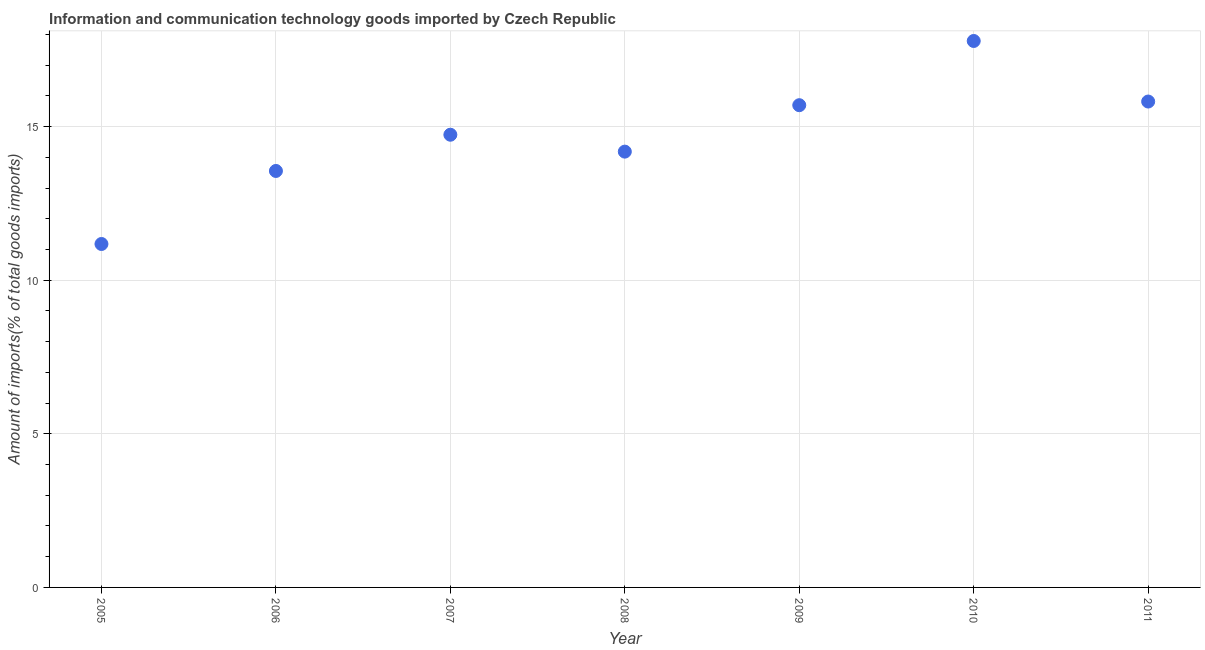What is the amount of ict goods imports in 2006?
Provide a succinct answer. 13.56. Across all years, what is the maximum amount of ict goods imports?
Your response must be concise. 17.79. Across all years, what is the minimum amount of ict goods imports?
Give a very brief answer. 11.18. In which year was the amount of ict goods imports minimum?
Your answer should be compact. 2005. What is the sum of the amount of ict goods imports?
Your answer should be compact. 102.95. What is the difference between the amount of ict goods imports in 2006 and 2008?
Offer a terse response. -0.63. What is the average amount of ict goods imports per year?
Provide a short and direct response. 14.71. What is the median amount of ict goods imports?
Offer a very short reply. 14.74. In how many years, is the amount of ict goods imports greater than 16 %?
Provide a short and direct response. 1. Do a majority of the years between 2009 and 2006 (inclusive) have amount of ict goods imports greater than 17 %?
Your answer should be very brief. Yes. What is the ratio of the amount of ict goods imports in 2007 to that in 2008?
Keep it short and to the point. 1.04. Is the amount of ict goods imports in 2006 less than that in 2009?
Provide a succinct answer. Yes. What is the difference between the highest and the second highest amount of ict goods imports?
Your answer should be very brief. 1.97. Is the sum of the amount of ict goods imports in 2008 and 2011 greater than the maximum amount of ict goods imports across all years?
Give a very brief answer. Yes. What is the difference between the highest and the lowest amount of ict goods imports?
Keep it short and to the point. 6.61. In how many years, is the amount of ict goods imports greater than the average amount of ict goods imports taken over all years?
Your answer should be compact. 4. How many dotlines are there?
Keep it short and to the point. 1. How many years are there in the graph?
Your answer should be very brief. 7. What is the difference between two consecutive major ticks on the Y-axis?
Provide a short and direct response. 5. Does the graph contain any zero values?
Ensure brevity in your answer.  No. What is the title of the graph?
Your answer should be compact. Information and communication technology goods imported by Czech Republic. What is the label or title of the Y-axis?
Ensure brevity in your answer.  Amount of imports(% of total goods imports). What is the Amount of imports(% of total goods imports) in 2005?
Your answer should be compact. 11.18. What is the Amount of imports(% of total goods imports) in 2006?
Provide a short and direct response. 13.56. What is the Amount of imports(% of total goods imports) in 2007?
Offer a terse response. 14.74. What is the Amount of imports(% of total goods imports) in 2008?
Offer a terse response. 14.19. What is the Amount of imports(% of total goods imports) in 2009?
Offer a very short reply. 15.7. What is the Amount of imports(% of total goods imports) in 2010?
Ensure brevity in your answer.  17.79. What is the Amount of imports(% of total goods imports) in 2011?
Make the answer very short. 15.82. What is the difference between the Amount of imports(% of total goods imports) in 2005 and 2006?
Offer a very short reply. -2.38. What is the difference between the Amount of imports(% of total goods imports) in 2005 and 2007?
Your response must be concise. -3.56. What is the difference between the Amount of imports(% of total goods imports) in 2005 and 2008?
Your answer should be compact. -3.01. What is the difference between the Amount of imports(% of total goods imports) in 2005 and 2009?
Provide a succinct answer. -4.52. What is the difference between the Amount of imports(% of total goods imports) in 2005 and 2010?
Make the answer very short. -6.61. What is the difference between the Amount of imports(% of total goods imports) in 2005 and 2011?
Offer a very short reply. -4.64. What is the difference between the Amount of imports(% of total goods imports) in 2006 and 2007?
Make the answer very short. -1.18. What is the difference between the Amount of imports(% of total goods imports) in 2006 and 2008?
Make the answer very short. -0.63. What is the difference between the Amount of imports(% of total goods imports) in 2006 and 2009?
Offer a terse response. -2.14. What is the difference between the Amount of imports(% of total goods imports) in 2006 and 2010?
Keep it short and to the point. -4.23. What is the difference between the Amount of imports(% of total goods imports) in 2006 and 2011?
Ensure brevity in your answer.  -2.26. What is the difference between the Amount of imports(% of total goods imports) in 2007 and 2008?
Give a very brief answer. 0.55. What is the difference between the Amount of imports(% of total goods imports) in 2007 and 2009?
Your answer should be compact. -0.96. What is the difference between the Amount of imports(% of total goods imports) in 2007 and 2010?
Provide a succinct answer. -3.05. What is the difference between the Amount of imports(% of total goods imports) in 2007 and 2011?
Offer a terse response. -1.08. What is the difference between the Amount of imports(% of total goods imports) in 2008 and 2009?
Provide a short and direct response. -1.51. What is the difference between the Amount of imports(% of total goods imports) in 2008 and 2010?
Give a very brief answer. -3.6. What is the difference between the Amount of imports(% of total goods imports) in 2008 and 2011?
Provide a short and direct response. -1.63. What is the difference between the Amount of imports(% of total goods imports) in 2009 and 2010?
Offer a very short reply. -2.09. What is the difference between the Amount of imports(% of total goods imports) in 2009 and 2011?
Offer a terse response. -0.12. What is the difference between the Amount of imports(% of total goods imports) in 2010 and 2011?
Make the answer very short. 1.97. What is the ratio of the Amount of imports(% of total goods imports) in 2005 to that in 2006?
Your answer should be compact. 0.82. What is the ratio of the Amount of imports(% of total goods imports) in 2005 to that in 2007?
Your response must be concise. 0.76. What is the ratio of the Amount of imports(% of total goods imports) in 2005 to that in 2008?
Ensure brevity in your answer.  0.79. What is the ratio of the Amount of imports(% of total goods imports) in 2005 to that in 2009?
Your answer should be compact. 0.71. What is the ratio of the Amount of imports(% of total goods imports) in 2005 to that in 2010?
Provide a short and direct response. 0.63. What is the ratio of the Amount of imports(% of total goods imports) in 2005 to that in 2011?
Make the answer very short. 0.71. What is the ratio of the Amount of imports(% of total goods imports) in 2006 to that in 2007?
Your answer should be compact. 0.92. What is the ratio of the Amount of imports(% of total goods imports) in 2006 to that in 2008?
Keep it short and to the point. 0.96. What is the ratio of the Amount of imports(% of total goods imports) in 2006 to that in 2009?
Your response must be concise. 0.86. What is the ratio of the Amount of imports(% of total goods imports) in 2006 to that in 2010?
Ensure brevity in your answer.  0.76. What is the ratio of the Amount of imports(% of total goods imports) in 2006 to that in 2011?
Offer a terse response. 0.86. What is the ratio of the Amount of imports(% of total goods imports) in 2007 to that in 2008?
Make the answer very short. 1.04. What is the ratio of the Amount of imports(% of total goods imports) in 2007 to that in 2009?
Your response must be concise. 0.94. What is the ratio of the Amount of imports(% of total goods imports) in 2007 to that in 2010?
Ensure brevity in your answer.  0.83. What is the ratio of the Amount of imports(% of total goods imports) in 2007 to that in 2011?
Your response must be concise. 0.93. What is the ratio of the Amount of imports(% of total goods imports) in 2008 to that in 2009?
Your answer should be very brief. 0.9. What is the ratio of the Amount of imports(% of total goods imports) in 2008 to that in 2010?
Keep it short and to the point. 0.8. What is the ratio of the Amount of imports(% of total goods imports) in 2008 to that in 2011?
Offer a very short reply. 0.9. What is the ratio of the Amount of imports(% of total goods imports) in 2009 to that in 2010?
Give a very brief answer. 0.88. What is the ratio of the Amount of imports(% of total goods imports) in 2010 to that in 2011?
Offer a terse response. 1.12. 